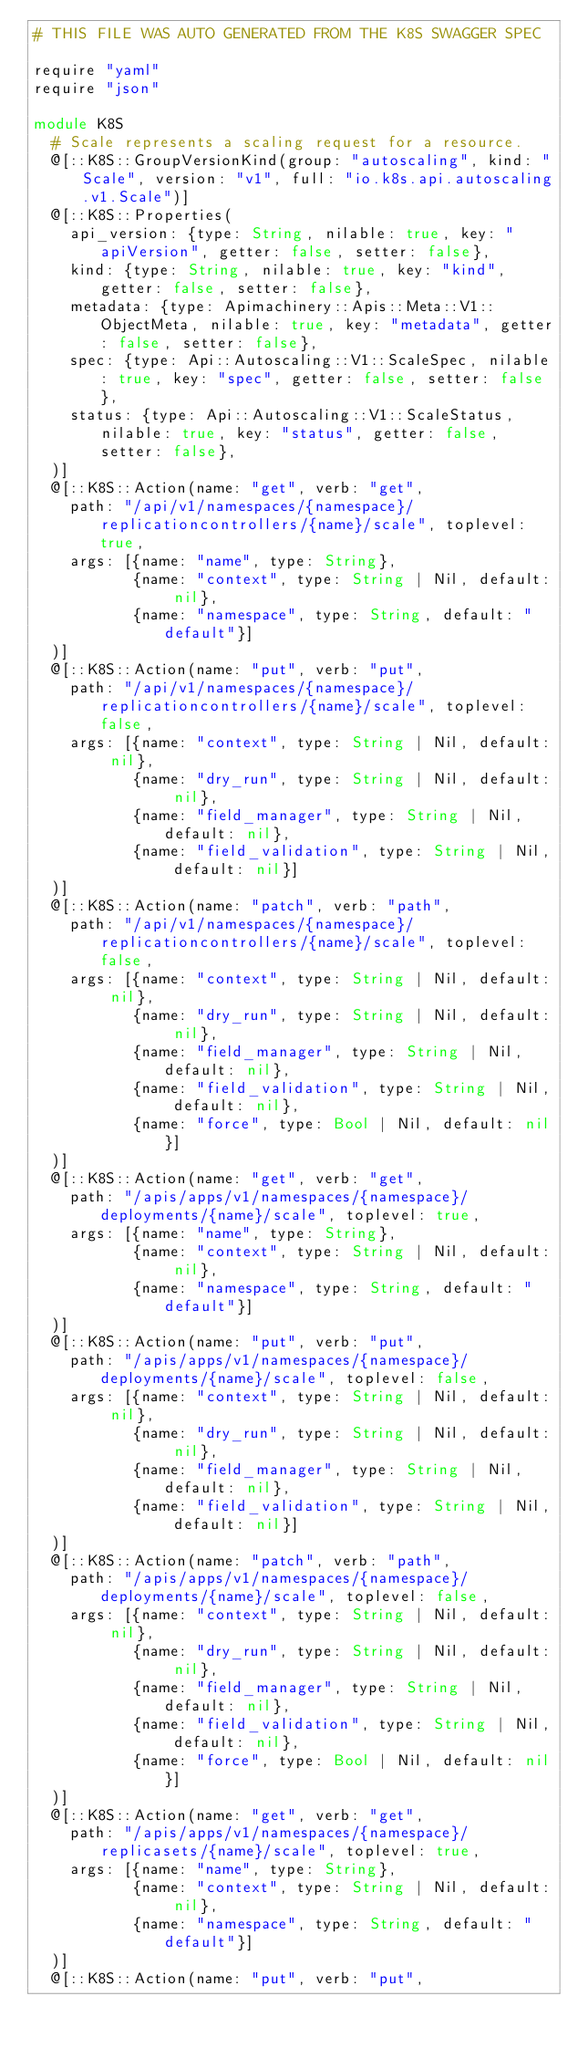Convert code to text. <code><loc_0><loc_0><loc_500><loc_500><_Crystal_># THIS FILE WAS AUTO GENERATED FROM THE K8S SWAGGER SPEC

require "yaml"
require "json"

module K8S
  # Scale represents a scaling request for a resource.
  @[::K8S::GroupVersionKind(group: "autoscaling", kind: "Scale", version: "v1", full: "io.k8s.api.autoscaling.v1.Scale")]
  @[::K8S::Properties(
    api_version: {type: String, nilable: true, key: "apiVersion", getter: false, setter: false},
    kind: {type: String, nilable: true, key: "kind", getter: false, setter: false},
    metadata: {type: Apimachinery::Apis::Meta::V1::ObjectMeta, nilable: true, key: "metadata", getter: false, setter: false},
    spec: {type: Api::Autoscaling::V1::ScaleSpec, nilable: true, key: "spec", getter: false, setter: false},
    status: {type: Api::Autoscaling::V1::ScaleStatus, nilable: true, key: "status", getter: false, setter: false},
  )]
  @[::K8S::Action(name: "get", verb: "get",
    path: "/api/v1/namespaces/{namespace}/replicationcontrollers/{name}/scale", toplevel: true,
    args: [{name: "name", type: String},
           {name: "context", type: String | Nil, default: nil},
           {name: "namespace", type: String, default: "default"}]
  )]
  @[::K8S::Action(name: "put", verb: "put",
    path: "/api/v1/namespaces/{namespace}/replicationcontrollers/{name}/scale", toplevel: false,
    args: [{name: "context", type: String | Nil, default: nil},
           {name: "dry_run", type: String | Nil, default: nil},
           {name: "field_manager", type: String | Nil, default: nil},
           {name: "field_validation", type: String | Nil, default: nil}]
  )]
  @[::K8S::Action(name: "patch", verb: "path",
    path: "/api/v1/namespaces/{namespace}/replicationcontrollers/{name}/scale", toplevel: false,
    args: [{name: "context", type: String | Nil, default: nil},
           {name: "dry_run", type: String | Nil, default: nil},
           {name: "field_manager", type: String | Nil, default: nil},
           {name: "field_validation", type: String | Nil, default: nil},
           {name: "force", type: Bool | Nil, default: nil}]
  )]
  @[::K8S::Action(name: "get", verb: "get",
    path: "/apis/apps/v1/namespaces/{namespace}/deployments/{name}/scale", toplevel: true,
    args: [{name: "name", type: String},
           {name: "context", type: String | Nil, default: nil},
           {name: "namespace", type: String, default: "default"}]
  )]
  @[::K8S::Action(name: "put", verb: "put",
    path: "/apis/apps/v1/namespaces/{namespace}/deployments/{name}/scale", toplevel: false,
    args: [{name: "context", type: String | Nil, default: nil},
           {name: "dry_run", type: String | Nil, default: nil},
           {name: "field_manager", type: String | Nil, default: nil},
           {name: "field_validation", type: String | Nil, default: nil}]
  )]
  @[::K8S::Action(name: "patch", verb: "path",
    path: "/apis/apps/v1/namespaces/{namespace}/deployments/{name}/scale", toplevel: false,
    args: [{name: "context", type: String | Nil, default: nil},
           {name: "dry_run", type: String | Nil, default: nil},
           {name: "field_manager", type: String | Nil, default: nil},
           {name: "field_validation", type: String | Nil, default: nil},
           {name: "force", type: Bool | Nil, default: nil}]
  )]
  @[::K8S::Action(name: "get", verb: "get",
    path: "/apis/apps/v1/namespaces/{namespace}/replicasets/{name}/scale", toplevel: true,
    args: [{name: "name", type: String},
           {name: "context", type: String | Nil, default: nil},
           {name: "namespace", type: String, default: "default"}]
  )]
  @[::K8S::Action(name: "put", verb: "put",</code> 